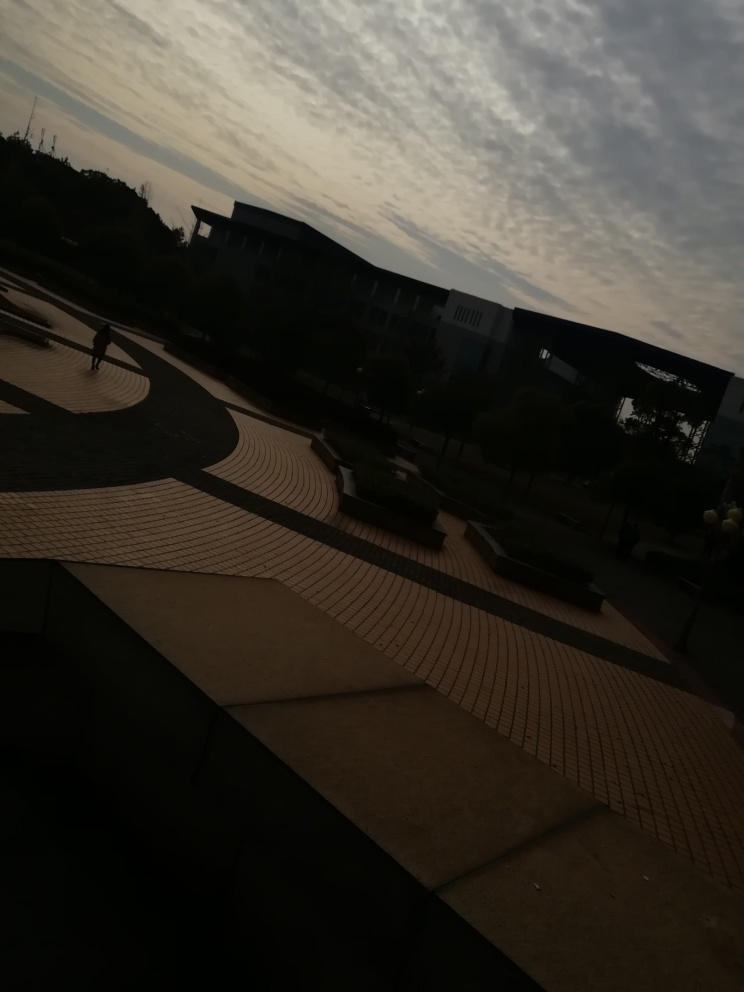What kind of weather or season does this photo suggest? The overcast sky and the lighting suggest it could either be a cloudy day or one experiencing the transition between seasons, possibly autumn or spring, when such cloud formations are common. The absence of leaves on the visible trees supports the idea of autumn, or it could be indicative of a location with trees that shed leaves during dry seasons. 